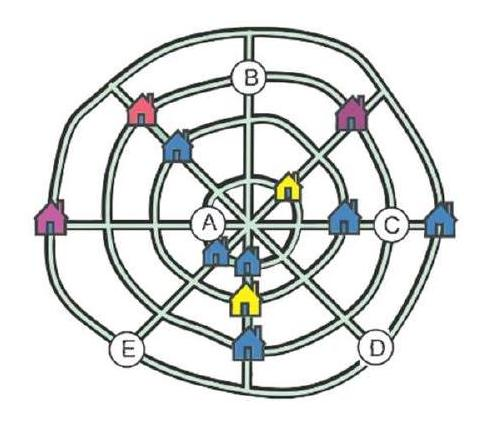What might be some benefits and drawbacks of this village layout? Benefits of this layout could include easy navigation due to its symmetry, as well as equitable distribution of land and resources among houses. However, drawbacks might include limited expansion options due to the rigid structure, and potential challenges in privacy, as the circular pattern could mean houses are positioned quite close to each other, depending on the actual scale and distances involved. 